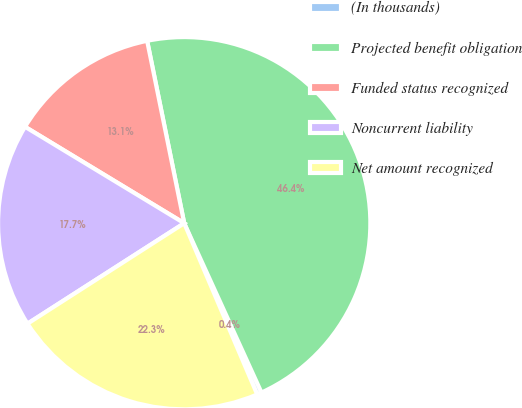Convert chart. <chart><loc_0><loc_0><loc_500><loc_500><pie_chart><fcel>(In thousands)<fcel>Projected benefit obligation<fcel>Funded status recognized<fcel>Noncurrent liability<fcel>Net amount recognized<nl><fcel>0.4%<fcel>46.38%<fcel>13.14%<fcel>17.74%<fcel>22.34%<nl></chart> 